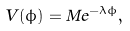Convert formula to latex. <formula><loc_0><loc_0><loc_500><loc_500>V ( \phi ) = M e ^ { - \lambda \phi } ,</formula> 